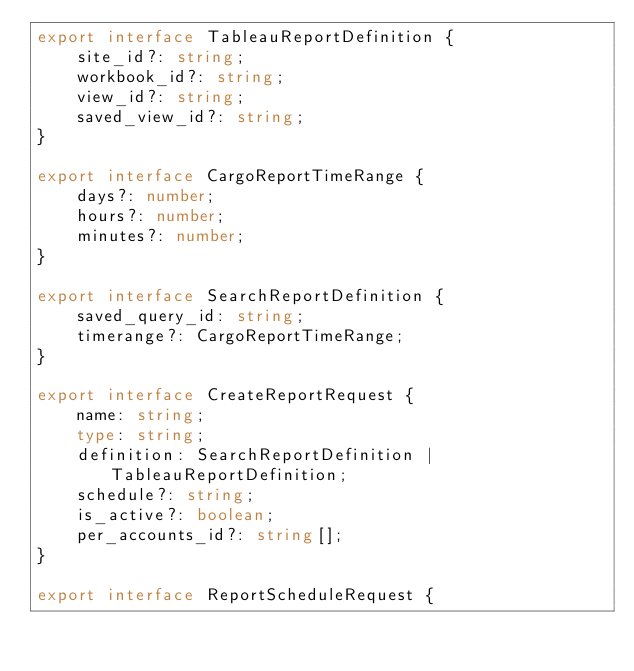<code> <loc_0><loc_0><loc_500><loc_500><_TypeScript_>export interface TableauReportDefinition {
    site_id?: string;
    workbook_id?: string;
    view_id?: string;
    saved_view_id?: string;
}

export interface CargoReportTimeRange {
    days?: number;
    hours?: number;
    minutes?: number;
}

export interface SearchReportDefinition {
    saved_query_id: string;
    timerange?: CargoReportTimeRange;
}

export interface CreateReportRequest {
    name: string;
    type: string;
    definition: SearchReportDefinition | TableauReportDefinition;
    schedule?: string;
    is_active?: boolean;
    per_accounts_id?: string[];
}

export interface ReportScheduleRequest {</code> 